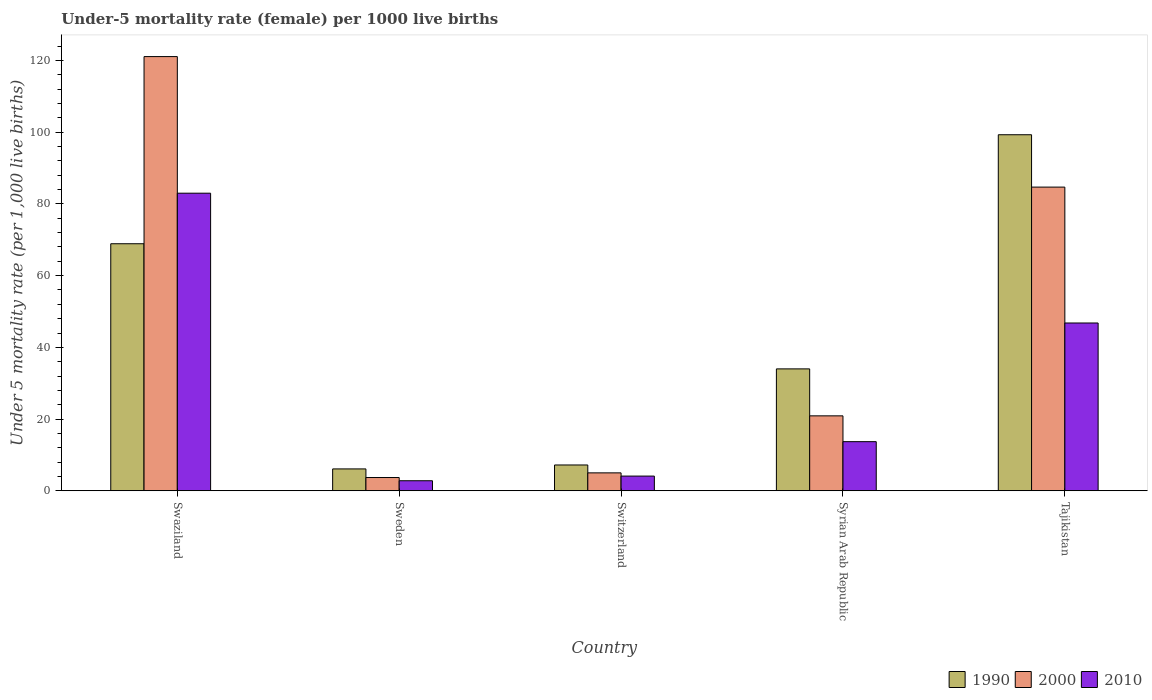How many different coloured bars are there?
Make the answer very short. 3. How many groups of bars are there?
Ensure brevity in your answer.  5. Are the number of bars per tick equal to the number of legend labels?
Make the answer very short. Yes. Are the number of bars on each tick of the X-axis equal?
Give a very brief answer. Yes. How many bars are there on the 5th tick from the left?
Provide a succinct answer. 3. What is the label of the 1st group of bars from the left?
Your answer should be compact. Swaziland. In how many cases, is the number of bars for a given country not equal to the number of legend labels?
Provide a succinct answer. 0. What is the under-five mortality rate in 1990 in Sweden?
Offer a very short reply. 6.1. Across all countries, what is the minimum under-five mortality rate in 2000?
Make the answer very short. 3.7. In which country was the under-five mortality rate in 2010 maximum?
Keep it short and to the point. Swaziland. What is the total under-five mortality rate in 2000 in the graph?
Ensure brevity in your answer.  235.4. What is the difference between the under-five mortality rate in 2000 in Sweden and that in Syrian Arab Republic?
Your answer should be compact. -17.2. What is the difference between the under-five mortality rate in 2000 in Sweden and the under-five mortality rate in 1990 in Swaziland?
Your answer should be compact. -65.2. What is the average under-five mortality rate in 2000 per country?
Offer a very short reply. 47.08. What is the difference between the under-five mortality rate of/in 2000 and under-five mortality rate of/in 2010 in Tajikistan?
Offer a very short reply. 37.9. What is the ratio of the under-five mortality rate in 1990 in Switzerland to that in Tajikistan?
Provide a succinct answer. 0.07. What is the difference between the highest and the second highest under-five mortality rate in 1990?
Your answer should be very brief. -65.3. What is the difference between the highest and the lowest under-five mortality rate in 2010?
Keep it short and to the point. 80.2. Is the sum of the under-five mortality rate in 2000 in Swaziland and Switzerland greater than the maximum under-five mortality rate in 2010 across all countries?
Your answer should be compact. Yes. What does the 3rd bar from the right in Syrian Arab Republic represents?
Give a very brief answer. 1990. Are all the bars in the graph horizontal?
Offer a terse response. No. How many countries are there in the graph?
Provide a short and direct response. 5. Does the graph contain any zero values?
Ensure brevity in your answer.  No. How many legend labels are there?
Ensure brevity in your answer.  3. What is the title of the graph?
Give a very brief answer. Under-5 mortality rate (female) per 1000 live births. Does "1986" appear as one of the legend labels in the graph?
Offer a very short reply. No. What is the label or title of the Y-axis?
Offer a terse response. Under 5 mortality rate (per 1,0 live births). What is the Under 5 mortality rate (per 1,000 live births) of 1990 in Swaziland?
Provide a short and direct response. 68.9. What is the Under 5 mortality rate (per 1,000 live births) of 2000 in Swaziland?
Provide a succinct answer. 121.1. What is the Under 5 mortality rate (per 1,000 live births) of 2010 in Swaziland?
Your response must be concise. 83. What is the Under 5 mortality rate (per 1,000 live births) of 2000 in Sweden?
Your response must be concise. 3.7. What is the Under 5 mortality rate (per 1,000 live births) of 2010 in Sweden?
Offer a very short reply. 2.8. What is the Under 5 mortality rate (per 1,000 live births) of 2000 in Switzerland?
Offer a terse response. 5. What is the Under 5 mortality rate (per 1,000 live births) of 2000 in Syrian Arab Republic?
Provide a short and direct response. 20.9. What is the Under 5 mortality rate (per 1,000 live births) of 2010 in Syrian Arab Republic?
Make the answer very short. 13.7. What is the Under 5 mortality rate (per 1,000 live births) in 1990 in Tajikistan?
Make the answer very short. 99.3. What is the Under 5 mortality rate (per 1,000 live births) of 2000 in Tajikistan?
Provide a succinct answer. 84.7. What is the Under 5 mortality rate (per 1,000 live births) of 2010 in Tajikistan?
Keep it short and to the point. 46.8. Across all countries, what is the maximum Under 5 mortality rate (per 1,000 live births) in 1990?
Keep it short and to the point. 99.3. Across all countries, what is the maximum Under 5 mortality rate (per 1,000 live births) in 2000?
Offer a terse response. 121.1. Across all countries, what is the minimum Under 5 mortality rate (per 1,000 live births) of 1990?
Make the answer very short. 6.1. What is the total Under 5 mortality rate (per 1,000 live births) of 1990 in the graph?
Offer a terse response. 215.5. What is the total Under 5 mortality rate (per 1,000 live births) of 2000 in the graph?
Keep it short and to the point. 235.4. What is the total Under 5 mortality rate (per 1,000 live births) of 2010 in the graph?
Offer a very short reply. 150.4. What is the difference between the Under 5 mortality rate (per 1,000 live births) in 1990 in Swaziland and that in Sweden?
Provide a short and direct response. 62.8. What is the difference between the Under 5 mortality rate (per 1,000 live births) in 2000 in Swaziland and that in Sweden?
Provide a succinct answer. 117.4. What is the difference between the Under 5 mortality rate (per 1,000 live births) of 2010 in Swaziland and that in Sweden?
Provide a succinct answer. 80.2. What is the difference between the Under 5 mortality rate (per 1,000 live births) in 1990 in Swaziland and that in Switzerland?
Provide a short and direct response. 61.7. What is the difference between the Under 5 mortality rate (per 1,000 live births) in 2000 in Swaziland and that in Switzerland?
Give a very brief answer. 116.1. What is the difference between the Under 5 mortality rate (per 1,000 live births) in 2010 in Swaziland and that in Switzerland?
Your answer should be very brief. 78.9. What is the difference between the Under 5 mortality rate (per 1,000 live births) in 1990 in Swaziland and that in Syrian Arab Republic?
Ensure brevity in your answer.  34.9. What is the difference between the Under 5 mortality rate (per 1,000 live births) of 2000 in Swaziland and that in Syrian Arab Republic?
Offer a very short reply. 100.2. What is the difference between the Under 5 mortality rate (per 1,000 live births) of 2010 in Swaziland and that in Syrian Arab Republic?
Your response must be concise. 69.3. What is the difference between the Under 5 mortality rate (per 1,000 live births) of 1990 in Swaziland and that in Tajikistan?
Provide a succinct answer. -30.4. What is the difference between the Under 5 mortality rate (per 1,000 live births) in 2000 in Swaziland and that in Tajikistan?
Give a very brief answer. 36.4. What is the difference between the Under 5 mortality rate (per 1,000 live births) of 2010 in Swaziland and that in Tajikistan?
Make the answer very short. 36.2. What is the difference between the Under 5 mortality rate (per 1,000 live births) in 2000 in Sweden and that in Switzerland?
Your answer should be compact. -1.3. What is the difference between the Under 5 mortality rate (per 1,000 live births) of 2010 in Sweden and that in Switzerland?
Give a very brief answer. -1.3. What is the difference between the Under 5 mortality rate (per 1,000 live births) of 1990 in Sweden and that in Syrian Arab Republic?
Your answer should be very brief. -27.9. What is the difference between the Under 5 mortality rate (per 1,000 live births) in 2000 in Sweden and that in Syrian Arab Republic?
Keep it short and to the point. -17.2. What is the difference between the Under 5 mortality rate (per 1,000 live births) in 2010 in Sweden and that in Syrian Arab Republic?
Give a very brief answer. -10.9. What is the difference between the Under 5 mortality rate (per 1,000 live births) in 1990 in Sweden and that in Tajikistan?
Ensure brevity in your answer.  -93.2. What is the difference between the Under 5 mortality rate (per 1,000 live births) of 2000 in Sweden and that in Tajikistan?
Offer a terse response. -81. What is the difference between the Under 5 mortality rate (per 1,000 live births) in 2010 in Sweden and that in Tajikistan?
Provide a short and direct response. -44. What is the difference between the Under 5 mortality rate (per 1,000 live births) of 1990 in Switzerland and that in Syrian Arab Republic?
Make the answer very short. -26.8. What is the difference between the Under 5 mortality rate (per 1,000 live births) in 2000 in Switzerland and that in Syrian Arab Republic?
Provide a short and direct response. -15.9. What is the difference between the Under 5 mortality rate (per 1,000 live births) of 1990 in Switzerland and that in Tajikistan?
Give a very brief answer. -92.1. What is the difference between the Under 5 mortality rate (per 1,000 live births) in 2000 in Switzerland and that in Tajikistan?
Make the answer very short. -79.7. What is the difference between the Under 5 mortality rate (per 1,000 live births) of 2010 in Switzerland and that in Tajikistan?
Ensure brevity in your answer.  -42.7. What is the difference between the Under 5 mortality rate (per 1,000 live births) of 1990 in Syrian Arab Republic and that in Tajikistan?
Keep it short and to the point. -65.3. What is the difference between the Under 5 mortality rate (per 1,000 live births) in 2000 in Syrian Arab Republic and that in Tajikistan?
Ensure brevity in your answer.  -63.8. What is the difference between the Under 5 mortality rate (per 1,000 live births) of 2010 in Syrian Arab Republic and that in Tajikistan?
Provide a succinct answer. -33.1. What is the difference between the Under 5 mortality rate (per 1,000 live births) in 1990 in Swaziland and the Under 5 mortality rate (per 1,000 live births) in 2000 in Sweden?
Ensure brevity in your answer.  65.2. What is the difference between the Under 5 mortality rate (per 1,000 live births) in 1990 in Swaziland and the Under 5 mortality rate (per 1,000 live births) in 2010 in Sweden?
Your response must be concise. 66.1. What is the difference between the Under 5 mortality rate (per 1,000 live births) in 2000 in Swaziland and the Under 5 mortality rate (per 1,000 live births) in 2010 in Sweden?
Make the answer very short. 118.3. What is the difference between the Under 5 mortality rate (per 1,000 live births) in 1990 in Swaziland and the Under 5 mortality rate (per 1,000 live births) in 2000 in Switzerland?
Your answer should be very brief. 63.9. What is the difference between the Under 5 mortality rate (per 1,000 live births) in 1990 in Swaziland and the Under 5 mortality rate (per 1,000 live births) in 2010 in Switzerland?
Give a very brief answer. 64.8. What is the difference between the Under 5 mortality rate (per 1,000 live births) in 2000 in Swaziland and the Under 5 mortality rate (per 1,000 live births) in 2010 in Switzerland?
Your answer should be very brief. 117. What is the difference between the Under 5 mortality rate (per 1,000 live births) of 1990 in Swaziland and the Under 5 mortality rate (per 1,000 live births) of 2010 in Syrian Arab Republic?
Your answer should be compact. 55.2. What is the difference between the Under 5 mortality rate (per 1,000 live births) of 2000 in Swaziland and the Under 5 mortality rate (per 1,000 live births) of 2010 in Syrian Arab Republic?
Provide a short and direct response. 107.4. What is the difference between the Under 5 mortality rate (per 1,000 live births) in 1990 in Swaziland and the Under 5 mortality rate (per 1,000 live births) in 2000 in Tajikistan?
Make the answer very short. -15.8. What is the difference between the Under 5 mortality rate (per 1,000 live births) in 1990 in Swaziland and the Under 5 mortality rate (per 1,000 live births) in 2010 in Tajikistan?
Give a very brief answer. 22.1. What is the difference between the Under 5 mortality rate (per 1,000 live births) of 2000 in Swaziland and the Under 5 mortality rate (per 1,000 live births) of 2010 in Tajikistan?
Offer a terse response. 74.3. What is the difference between the Under 5 mortality rate (per 1,000 live births) in 2000 in Sweden and the Under 5 mortality rate (per 1,000 live births) in 2010 in Switzerland?
Offer a terse response. -0.4. What is the difference between the Under 5 mortality rate (per 1,000 live births) of 1990 in Sweden and the Under 5 mortality rate (per 1,000 live births) of 2000 in Syrian Arab Republic?
Your answer should be compact. -14.8. What is the difference between the Under 5 mortality rate (per 1,000 live births) in 1990 in Sweden and the Under 5 mortality rate (per 1,000 live births) in 2010 in Syrian Arab Republic?
Make the answer very short. -7.6. What is the difference between the Under 5 mortality rate (per 1,000 live births) of 2000 in Sweden and the Under 5 mortality rate (per 1,000 live births) of 2010 in Syrian Arab Republic?
Provide a succinct answer. -10. What is the difference between the Under 5 mortality rate (per 1,000 live births) in 1990 in Sweden and the Under 5 mortality rate (per 1,000 live births) in 2000 in Tajikistan?
Provide a succinct answer. -78.6. What is the difference between the Under 5 mortality rate (per 1,000 live births) in 1990 in Sweden and the Under 5 mortality rate (per 1,000 live births) in 2010 in Tajikistan?
Ensure brevity in your answer.  -40.7. What is the difference between the Under 5 mortality rate (per 1,000 live births) of 2000 in Sweden and the Under 5 mortality rate (per 1,000 live births) of 2010 in Tajikistan?
Offer a terse response. -43.1. What is the difference between the Under 5 mortality rate (per 1,000 live births) in 1990 in Switzerland and the Under 5 mortality rate (per 1,000 live births) in 2000 in Syrian Arab Republic?
Give a very brief answer. -13.7. What is the difference between the Under 5 mortality rate (per 1,000 live births) in 2000 in Switzerland and the Under 5 mortality rate (per 1,000 live births) in 2010 in Syrian Arab Republic?
Your answer should be compact. -8.7. What is the difference between the Under 5 mortality rate (per 1,000 live births) of 1990 in Switzerland and the Under 5 mortality rate (per 1,000 live births) of 2000 in Tajikistan?
Your response must be concise. -77.5. What is the difference between the Under 5 mortality rate (per 1,000 live births) of 1990 in Switzerland and the Under 5 mortality rate (per 1,000 live births) of 2010 in Tajikistan?
Make the answer very short. -39.6. What is the difference between the Under 5 mortality rate (per 1,000 live births) in 2000 in Switzerland and the Under 5 mortality rate (per 1,000 live births) in 2010 in Tajikistan?
Offer a terse response. -41.8. What is the difference between the Under 5 mortality rate (per 1,000 live births) in 1990 in Syrian Arab Republic and the Under 5 mortality rate (per 1,000 live births) in 2000 in Tajikistan?
Keep it short and to the point. -50.7. What is the difference between the Under 5 mortality rate (per 1,000 live births) in 1990 in Syrian Arab Republic and the Under 5 mortality rate (per 1,000 live births) in 2010 in Tajikistan?
Offer a terse response. -12.8. What is the difference between the Under 5 mortality rate (per 1,000 live births) in 2000 in Syrian Arab Republic and the Under 5 mortality rate (per 1,000 live births) in 2010 in Tajikistan?
Provide a succinct answer. -25.9. What is the average Under 5 mortality rate (per 1,000 live births) of 1990 per country?
Provide a short and direct response. 43.1. What is the average Under 5 mortality rate (per 1,000 live births) in 2000 per country?
Keep it short and to the point. 47.08. What is the average Under 5 mortality rate (per 1,000 live births) of 2010 per country?
Offer a terse response. 30.08. What is the difference between the Under 5 mortality rate (per 1,000 live births) in 1990 and Under 5 mortality rate (per 1,000 live births) in 2000 in Swaziland?
Offer a very short reply. -52.2. What is the difference between the Under 5 mortality rate (per 1,000 live births) in 1990 and Under 5 mortality rate (per 1,000 live births) in 2010 in Swaziland?
Ensure brevity in your answer.  -14.1. What is the difference between the Under 5 mortality rate (per 1,000 live births) in 2000 and Under 5 mortality rate (per 1,000 live births) in 2010 in Swaziland?
Ensure brevity in your answer.  38.1. What is the difference between the Under 5 mortality rate (per 1,000 live births) in 1990 and Under 5 mortality rate (per 1,000 live births) in 2010 in Sweden?
Offer a very short reply. 3.3. What is the difference between the Under 5 mortality rate (per 1,000 live births) in 2000 and Under 5 mortality rate (per 1,000 live births) in 2010 in Switzerland?
Ensure brevity in your answer.  0.9. What is the difference between the Under 5 mortality rate (per 1,000 live births) in 1990 and Under 5 mortality rate (per 1,000 live births) in 2010 in Syrian Arab Republic?
Make the answer very short. 20.3. What is the difference between the Under 5 mortality rate (per 1,000 live births) in 1990 and Under 5 mortality rate (per 1,000 live births) in 2010 in Tajikistan?
Offer a terse response. 52.5. What is the difference between the Under 5 mortality rate (per 1,000 live births) of 2000 and Under 5 mortality rate (per 1,000 live births) of 2010 in Tajikistan?
Provide a short and direct response. 37.9. What is the ratio of the Under 5 mortality rate (per 1,000 live births) of 1990 in Swaziland to that in Sweden?
Offer a very short reply. 11.3. What is the ratio of the Under 5 mortality rate (per 1,000 live births) of 2000 in Swaziland to that in Sweden?
Give a very brief answer. 32.73. What is the ratio of the Under 5 mortality rate (per 1,000 live births) in 2010 in Swaziland to that in Sweden?
Your answer should be compact. 29.64. What is the ratio of the Under 5 mortality rate (per 1,000 live births) of 1990 in Swaziland to that in Switzerland?
Keep it short and to the point. 9.57. What is the ratio of the Under 5 mortality rate (per 1,000 live births) in 2000 in Swaziland to that in Switzerland?
Offer a terse response. 24.22. What is the ratio of the Under 5 mortality rate (per 1,000 live births) in 2010 in Swaziland to that in Switzerland?
Provide a succinct answer. 20.24. What is the ratio of the Under 5 mortality rate (per 1,000 live births) in 1990 in Swaziland to that in Syrian Arab Republic?
Provide a short and direct response. 2.03. What is the ratio of the Under 5 mortality rate (per 1,000 live births) in 2000 in Swaziland to that in Syrian Arab Republic?
Your answer should be compact. 5.79. What is the ratio of the Under 5 mortality rate (per 1,000 live births) in 2010 in Swaziland to that in Syrian Arab Republic?
Provide a short and direct response. 6.06. What is the ratio of the Under 5 mortality rate (per 1,000 live births) of 1990 in Swaziland to that in Tajikistan?
Give a very brief answer. 0.69. What is the ratio of the Under 5 mortality rate (per 1,000 live births) of 2000 in Swaziland to that in Tajikistan?
Your answer should be very brief. 1.43. What is the ratio of the Under 5 mortality rate (per 1,000 live births) in 2010 in Swaziland to that in Tajikistan?
Ensure brevity in your answer.  1.77. What is the ratio of the Under 5 mortality rate (per 1,000 live births) of 1990 in Sweden to that in Switzerland?
Give a very brief answer. 0.85. What is the ratio of the Under 5 mortality rate (per 1,000 live births) in 2000 in Sweden to that in Switzerland?
Provide a succinct answer. 0.74. What is the ratio of the Under 5 mortality rate (per 1,000 live births) of 2010 in Sweden to that in Switzerland?
Provide a succinct answer. 0.68. What is the ratio of the Under 5 mortality rate (per 1,000 live births) of 1990 in Sweden to that in Syrian Arab Republic?
Provide a short and direct response. 0.18. What is the ratio of the Under 5 mortality rate (per 1,000 live births) of 2000 in Sweden to that in Syrian Arab Republic?
Offer a terse response. 0.18. What is the ratio of the Under 5 mortality rate (per 1,000 live births) in 2010 in Sweden to that in Syrian Arab Republic?
Give a very brief answer. 0.2. What is the ratio of the Under 5 mortality rate (per 1,000 live births) of 1990 in Sweden to that in Tajikistan?
Offer a terse response. 0.06. What is the ratio of the Under 5 mortality rate (per 1,000 live births) in 2000 in Sweden to that in Tajikistan?
Your response must be concise. 0.04. What is the ratio of the Under 5 mortality rate (per 1,000 live births) in 2010 in Sweden to that in Tajikistan?
Ensure brevity in your answer.  0.06. What is the ratio of the Under 5 mortality rate (per 1,000 live births) of 1990 in Switzerland to that in Syrian Arab Republic?
Make the answer very short. 0.21. What is the ratio of the Under 5 mortality rate (per 1,000 live births) of 2000 in Switzerland to that in Syrian Arab Republic?
Provide a short and direct response. 0.24. What is the ratio of the Under 5 mortality rate (per 1,000 live births) in 2010 in Switzerland to that in Syrian Arab Republic?
Make the answer very short. 0.3. What is the ratio of the Under 5 mortality rate (per 1,000 live births) in 1990 in Switzerland to that in Tajikistan?
Make the answer very short. 0.07. What is the ratio of the Under 5 mortality rate (per 1,000 live births) of 2000 in Switzerland to that in Tajikistan?
Provide a succinct answer. 0.06. What is the ratio of the Under 5 mortality rate (per 1,000 live births) in 2010 in Switzerland to that in Tajikistan?
Your response must be concise. 0.09. What is the ratio of the Under 5 mortality rate (per 1,000 live births) in 1990 in Syrian Arab Republic to that in Tajikistan?
Offer a terse response. 0.34. What is the ratio of the Under 5 mortality rate (per 1,000 live births) of 2000 in Syrian Arab Republic to that in Tajikistan?
Give a very brief answer. 0.25. What is the ratio of the Under 5 mortality rate (per 1,000 live births) in 2010 in Syrian Arab Republic to that in Tajikistan?
Your response must be concise. 0.29. What is the difference between the highest and the second highest Under 5 mortality rate (per 1,000 live births) in 1990?
Your answer should be very brief. 30.4. What is the difference between the highest and the second highest Under 5 mortality rate (per 1,000 live births) of 2000?
Keep it short and to the point. 36.4. What is the difference between the highest and the second highest Under 5 mortality rate (per 1,000 live births) in 2010?
Make the answer very short. 36.2. What is the difference between the highest and the lowest Under 5 mortality rate (per 1,000 live births) of 1990?
Keep it short and to the point. 93.2. What is the difference between the highest and the lowest Under 5 mortality rate (per 1,000 live births) in 2000?
Give a very brief answer. 117.4. What is the difference between the highest and the lowest Under 5 mortality rate (per 1,000 live births) in 2010?
Ensure brevity in your answer.  80.2. 